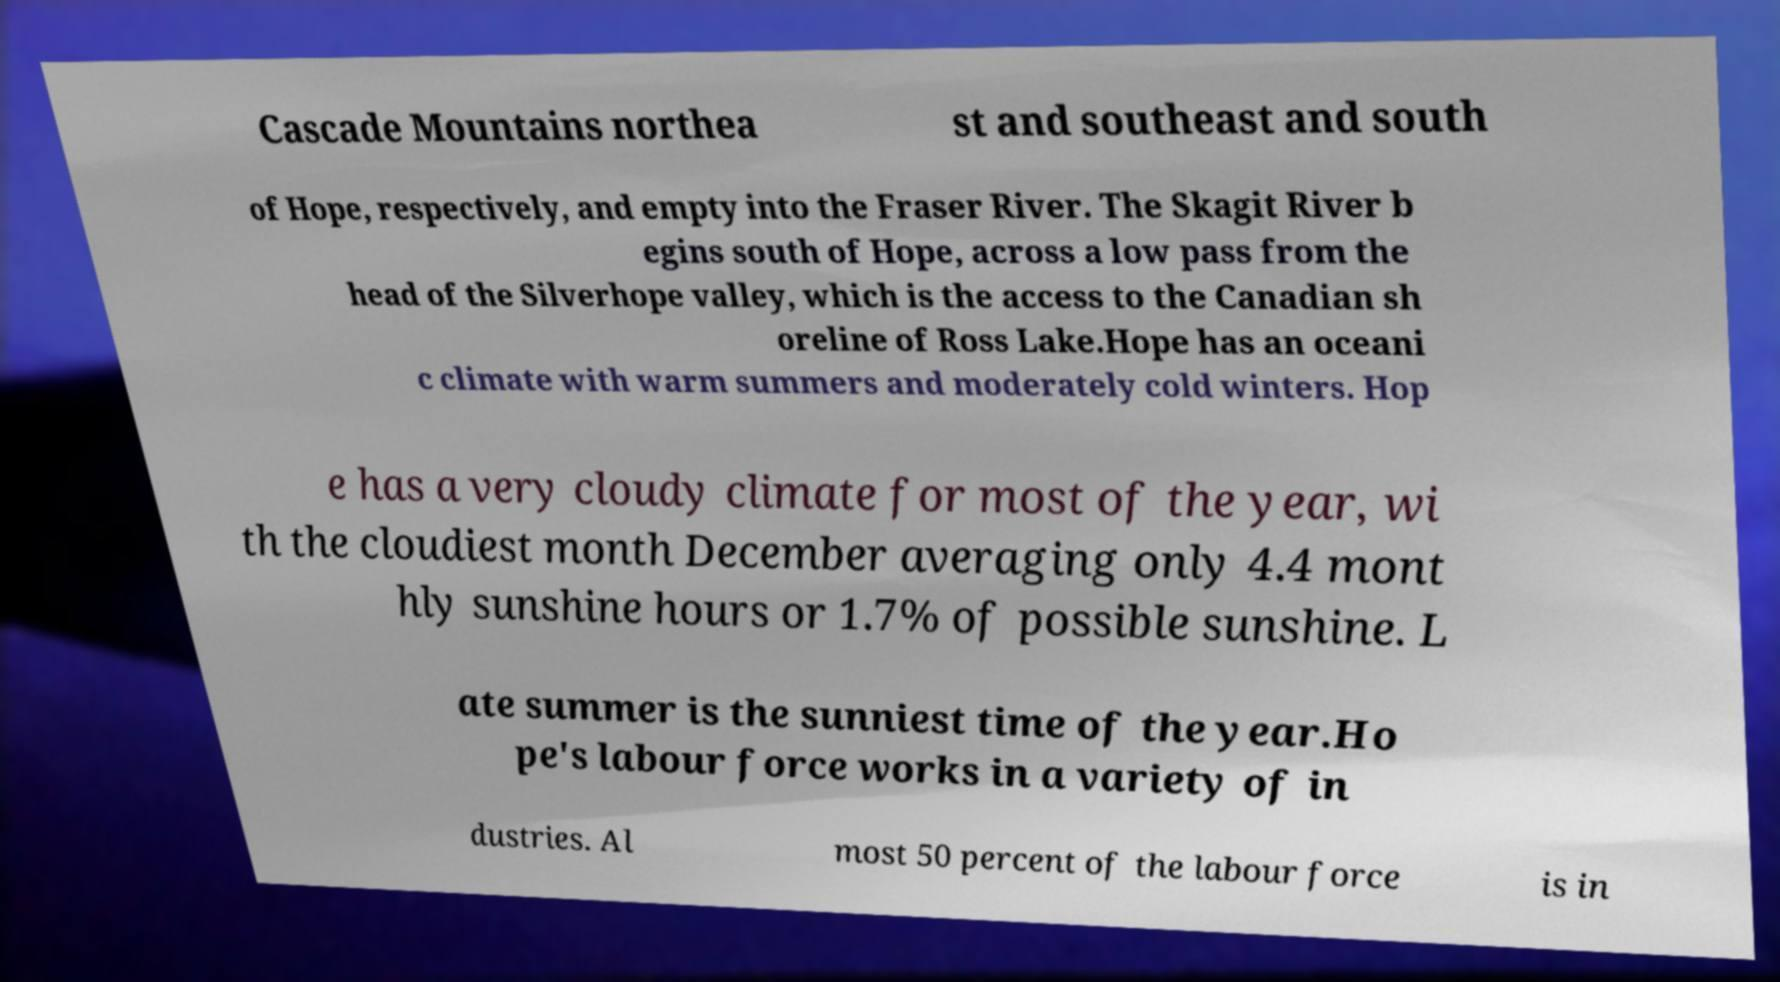For documentation purposes, I need the text within this image transcribed. Could you provide that? Cascade Mountains northea st and southeast and south of Hope, respectively, and empty into the Fraser River. The Skagit River b egins south of Hope, across a low pass from the head of the Silverhope valley, which is the access to the Canadian sh oreline of Ross Lake.Hope has an oceani c climate with warm summers and moderately cold winters. Hop e has a very cloudy climate for most of the year, wi th the cloudiest month December averaging only 4.4 mont hly sunshine hours or 1.7% of possible sunshine. L ate summer is the sunniest time of the year.Ho pe's labour force works in a variety of in dustries. Al most 50 percent of the labour force is in 